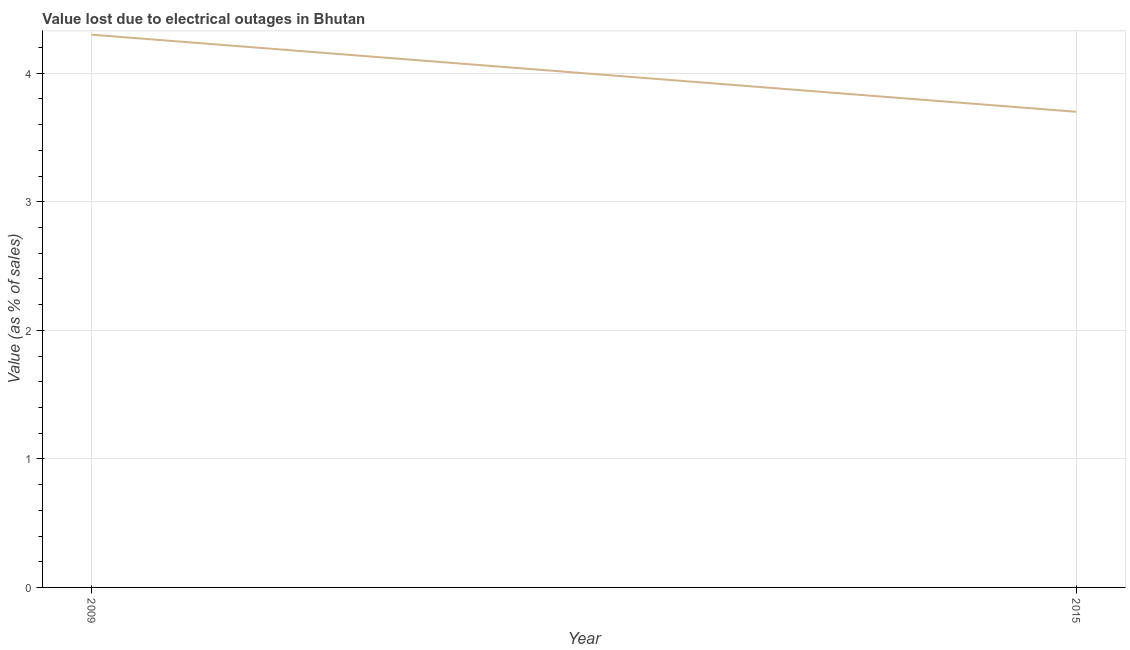Across all years, what is the maximum value lost due to electrical outages?
Provide a succinct answer. 4.3. Across all years, what is the minimum value lost due to electrical outages?
Provide a succinct answer. 3.7. In which year was the value lost due to electrical outages maximum?
Offer a terse response. 2009. In which year was the value lost due to electrical outages minimum?
Make the answer very short. 2015. What is the difference between the value lost due to electrical outages in 2009 and 2015?
Offer a terse response. 0.6. What is the median value lost due to electrical outages?
Give a very brief answer. 4. Do a majority of the years between 2009 and 2015 (inclusive) have value lost due to electrical outages greater than 0.6000000000000001 %?
Give a very brief answer. Yes. What is the ratio of the value lost due to electrical outages in 2009 to that in 2015?
Ensure brevity in your answer.  1.16. Is the value lost due to electrical outages in 2009 less than that in 2015?
Offer a very short reply. No. How many lines are there?
Give a very brief answer. 1. How many years are there in the graph?
Keep it short and to the point. 2. What is the title of the graph?
Your response must be concise. Value lost due to electrical outages in Bhutan. What is the label or title of the X-axis?
Offer a terse response. Year. What is the label or title of the Y-axis?
Provide a short and direct response. Value (as % of sales). What is the Value (as % of sales) of 2009?
Your response must be concise. 4.3. What is the Value (as % of sales) in 2015?
Your response must be concise. 3.7. What is the difference between the Value (as % of sales) in 2009 and 2015?
Ensure brevity in your answer.  0.6. What is the ratio of the Value (as % of sales) in 2009 to that in 2015?
Make the answer very short. 1.16. 